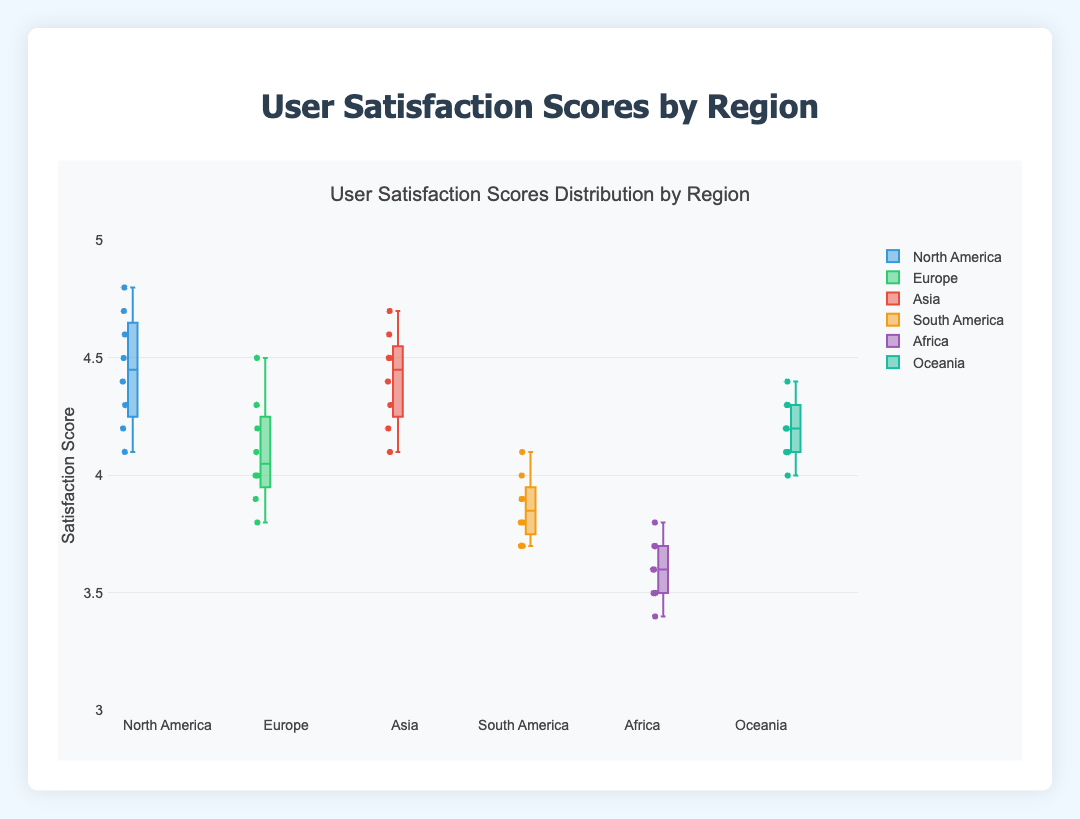Which region has the highest median user satisfaction score? From the box plot, the line in the middle of each box represents the median. The region with the highest median line is North America.
Answer: North America What is the range of satisfaction scores for Africa? The range is determined by the minimum and maximum points. For Africa, it appears the scores range from 3.4 to 3.8.
Answer: 3.4 to 3.8 Which region has the lowest minimum satisfaction score? The lowest minimum score is indicated by the bottom of the whisker. The shortest whisker is seen in Africa, with a minimum score of 3.4.
Answer: Africa Which region has the most consistent user satisfaction scores? Consistency can be observed by looking at the interquartile range (IQR, the box), where a smaller IQR suggests more consistent scores. Both Asia and North America have relatively small IQRs, but Asia seems slightly smaller.
Answer: Asia Compare the median satisfaction scores of Europe and South America. The median score (the line inside the box) for Europe is around 4.0, while for South America it is also around 3.9. Europe’s median is slightly higher.
Answer: Europe > South America Is there any overlap in user satisfaction scores between Europe and Asia? Overlap can be seen if there are parts of the boxes or whiskers touching or extending into each other's range. Both Europe (3.8 to 4.5) and Asia (4.1 to 4.7) overlap in the range of 4.1 to 4.5.
Answer: Yes What is the interquartile range (IQR) for Oceania? IQR is the difference between the 1st quartile (Q1) and the 3rd quartile (Q3). For Oceania, Q1 is around 4.1 and Q3 is around 4.3, so the IQR is about 0.2.
Answer: 0.2 Which region shows the greatest variability in user satisfaction scores? Variability is indicated by the total length of the whiskers and the box. Africa shows the greatest variability with scores ranging from 3.4 to 3.8 and a wider IQR.
Answer: Africa 